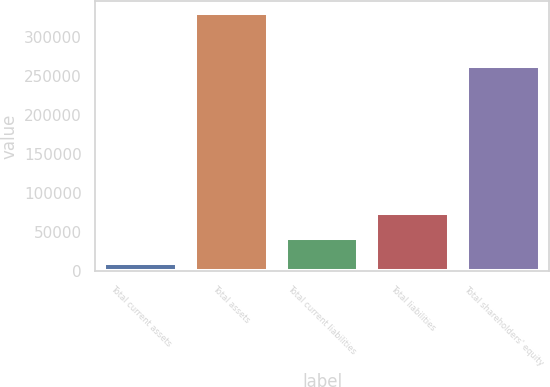Convert chart. <chart><loc_0><loc_0><loc_500><loc_500><bar_chart><fcel>Total current assets<fcel>Total assets<fcel>Total current liabilities<fcel>Total liabilities<fcel>Total shareholders' equity<nl><fcel>10332<fcel>329653<fcel>42264.1<fcel>74196.2<fcel>262566<nl></chart> 